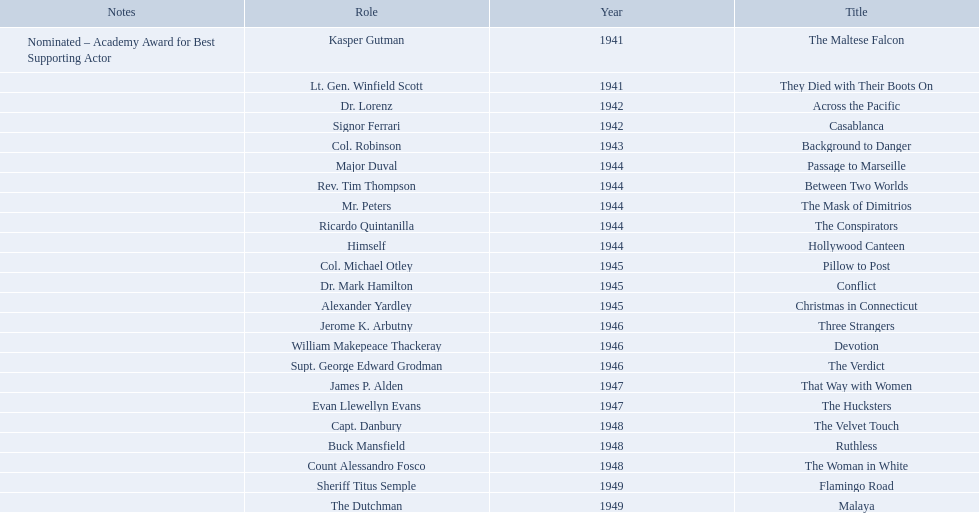What year was the movie that was nominated ? 1941. What was the title of the movie? The Maltese Falcon. 